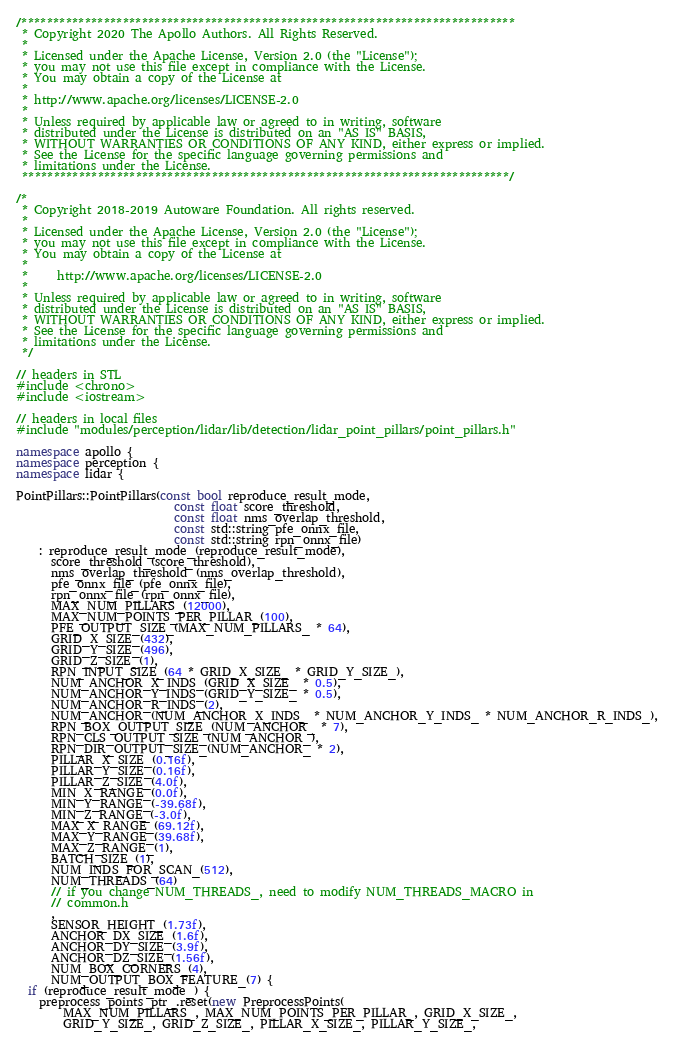<code> <loc_0><loc_0><loc_500><loc_500><_C++_>/******************************************************************************
 * Copyright 2020 The Apollo Authors. All Rights Reserved.
 *
 * Licensed under the Apache License, Version 2.0 (the "License");
 * you may not use this file except in compliance with the License.
 * You may obtain a copy of the License at
 *
 * http://www.apache.org/licenses/LICENSE-2.0
 *
 * Unless required by applicable law or agreed to in writing, software
 * distributed under the License is distributed on an "AS IS" BASIS,
 * WITHOUT WARRANTIES OR CONDITIONS OF ANY KIND, either express or implied.
 * See the License for the specific language governing permissions and
 * limitations under the License.
 *****************************************************************************/

/*
 * Copyright 2018-2019 Autoware Foundation. All rights reserved.
 *
 * Licensed under the Apache License, Version 2.0 (the "License");
 * you may not use this file except in compliance with the License.
 * You may obtain a copy of the License at
 *
 *     http://www.apache.org/licenses/LICENSE-2.0
 *
 * Unless required by applicable law or agreed to in writing, software
 * distributed under the License is distributed on an "AS IS" BASIS,
 * WITHOUT WARRANTIES OR CONDITIONS OF ANY KIND, either express or implied.
 * See the License for the specific language governing permissions and
 * limitations under the License.
 */

// headers in STL
#include <chrono>
#include <iostream>

// headers in local files
#include "modules/perception/lidar/lib/detection/lidar_point_pillars/point_pillars.h"

namespace apollo {
namespace perception {
namespace lidar {

PointPillars::PointPillars(const bool reproduce_result_mode,
                           const float score_threshold,
                           const float nms_overlap_threshold,
                           const std::string pfe_onnx_file,
                           const std::string rpn_onnx_file)
    : reproduce_result_mode_(reproduce_result_mode),
      score_threshold_(score_threshold),
      nms_overlap_threshold_(nms_overlap_threshold),
      pfe_onnx_file_(pfe_onnx_file),
      rpn_onnx_file_(rpn_onnx_file),
      MAX_NUM_PILLARS_(12000),
      MAX_NUM_POINTS_PER_PILLAR_(100),
      PFE_OUTPUT_SIZE_(MAX_NUM_PILLARS_ * 64),
      GRID_X_SIZE_(432),
      GRID_Y_SIZE_(496),
      GRID_Z_SIZE_(1),
      RPN_INPUT_SIZE_(64 * GRID_X_SIZE_ * GRID_Y_SIZE_),
      NUM_ANCHOR_X_INDS_(GRID_X_SIZE_ * 0.5),
      NUM_ANCHOR_Y_INDS_(GRID_Y_SIZE_ * 0.5),
      NUM_ANCHOR_R_INDS_(2),
      NUM_ANCHOR_(NUM_ANCHOR_X_INDS_ * NUM_ANCHOR_Y_INDS_ * NUM_ANCHOR_R_INDS_),
      RPN_BOX_OUTPUT_SIZE_(NUM_ANCHOR_ * 7),
      RPN_CLS_OUTPUT_SIZE_(NUM_ANCHOR_),
      RPN_DIR_OUTPUT_SIZE_(NUM_ANCHOR_ * 2),
      PILLAR_X_SIZE_(0.16f),
      PILLAR_Y_SIZE_(0.16f),
      PILLAR_Z_SIZE_(4.0f),
      MIN_X_RANGE_(0.0f),
      MIN_Y_RANGE_(-39.68f),
      MIN_Z_RANGE_(-3.0f),
      MAX_X_RANGE_(69.12f),
      MAX_Y_RANGE_(39.68f),
      MAX_Z_RANGE_(1),
      BATCH_SIZE_(1),
      NUM_INDS_FOR_SCAN_(512),
      NUM_THREADS_(64)
      // if you change NUM_THREADS_, need to modify NUM_THREADS_MACRO in
      // common.h
      ,
      SENSOR_HEIGHT_(1.73f),
      ANCHOR_DX_SIZE_(1.6f),
      ANCHOR_DY_SIZE_(3.9f),
      ANCHOR_DZ_SIZE_(1.56f),
      NUM_BOX_CORNERS_(4),
      NUM_OUTPUT_BOX_FEATURE_(7) {
  if (reproduce_result_mode_) {
    preprocess_points_ptr_.reset(new PreprocessPoints(
        MAX_NUM_PILLARS_, MAX_NUM_POINTS_PER_PILLAR_, GRID_X_SIZE_,
        GRID_Y_SIZE_, GRID_Z_SIZE_, PILLAR_X_SIZE_, PILLAR_Y_SIZE_,</code> 